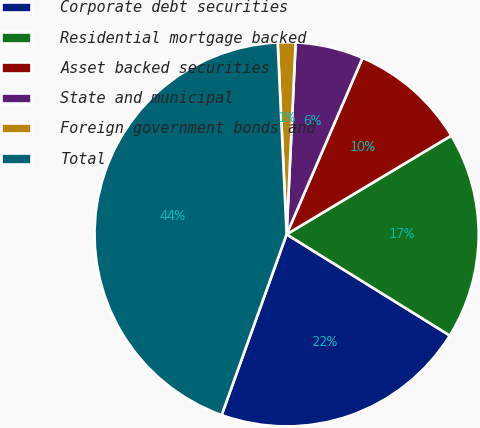<chart> <loc_0><loc_0><loc_500><loc_500><pie_chart><fcel>Corporate debt securities<fcel>Residential mortgage backed<fcel>Asset backed securities<fcel>State and municipal<fcel>Foreign government bonds and<fcel>Total<nl><fcel>21.66%<fcel>17.43%<fcel>9.94%<fcel>5.72%<fcel>1.49%<fcel>43.77%<nl></chart> 